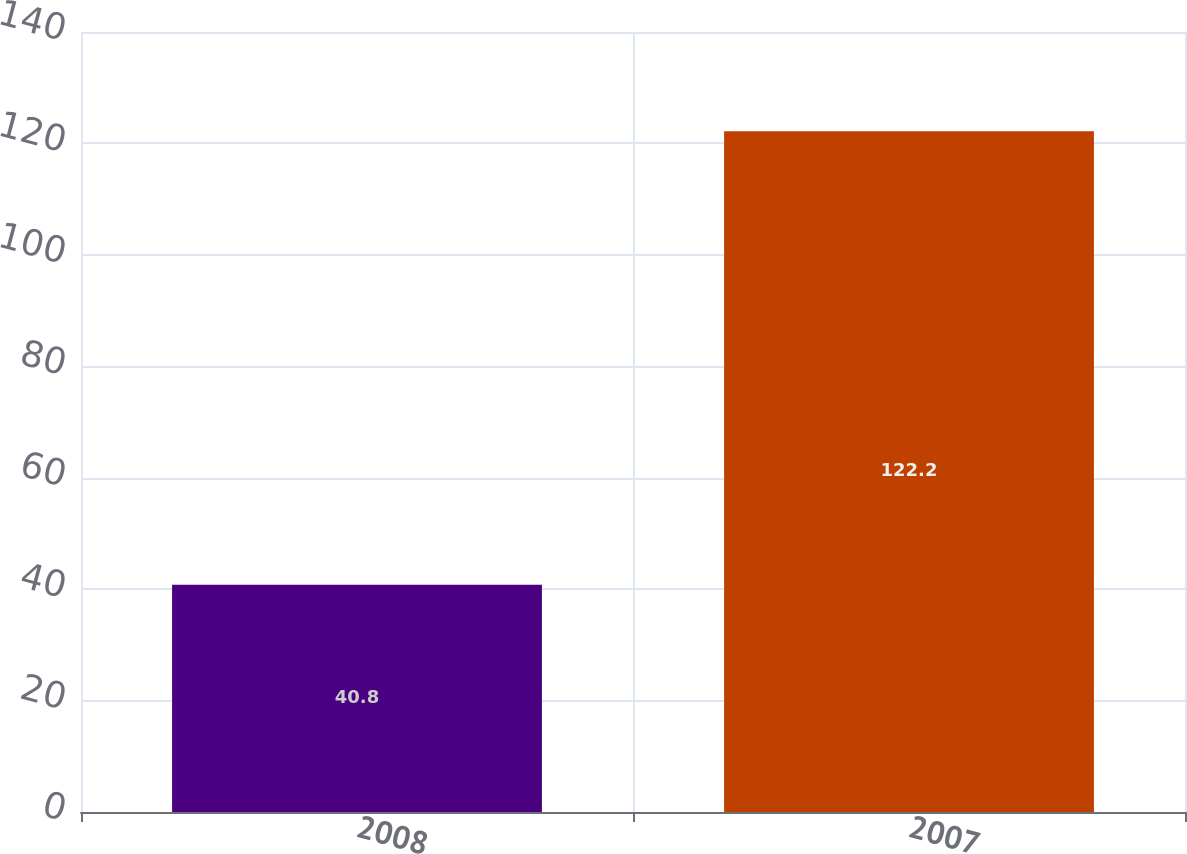Convert chart to OTSL. <chart><loc_0><loc_0><loc_500><loc_500><bar_chart><fcel>2008<fcel>2007<nl><fcel>40.8<fcel>122.2<nl></chart> 